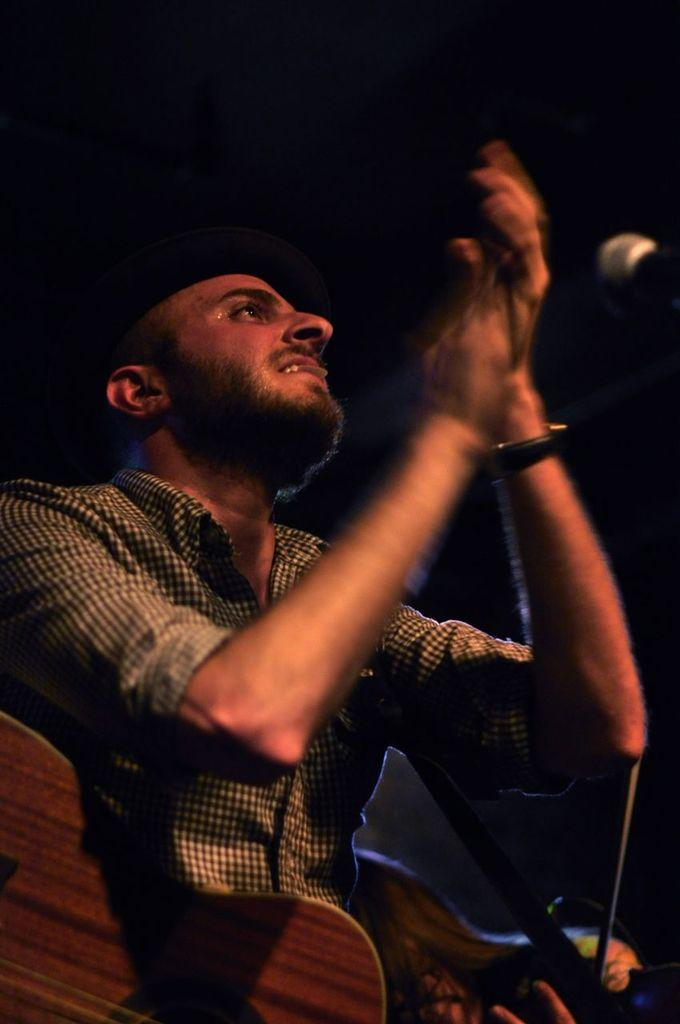Who is the main subject in the image? There is a man in the image. What object is the man holding in the image? The man is holding a watch in his hand. What musical instrument is present in the image? There is a guitar in the image. What device is used for amplifying sound in the image? There is a microphone (mic) in the image. How many snakes are wrapped around the guitar in the image? There are no snakes present in the image; it only features a man, a guitar, a microphone, and a watch. What type of eggnog is being served in the image? There is no eggnog present in the image. 